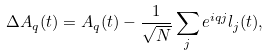Convert formula to latex. <formula><loc_0><loc_0><loc_500><loc_500>\Delta A _ { q } ( t ) = A _ { q } ( t ) - \frac { 1 } { \sqrt { N } } \sum _ { j } e ^ { i q j } l _ { j } ( t ) ,</formula> 